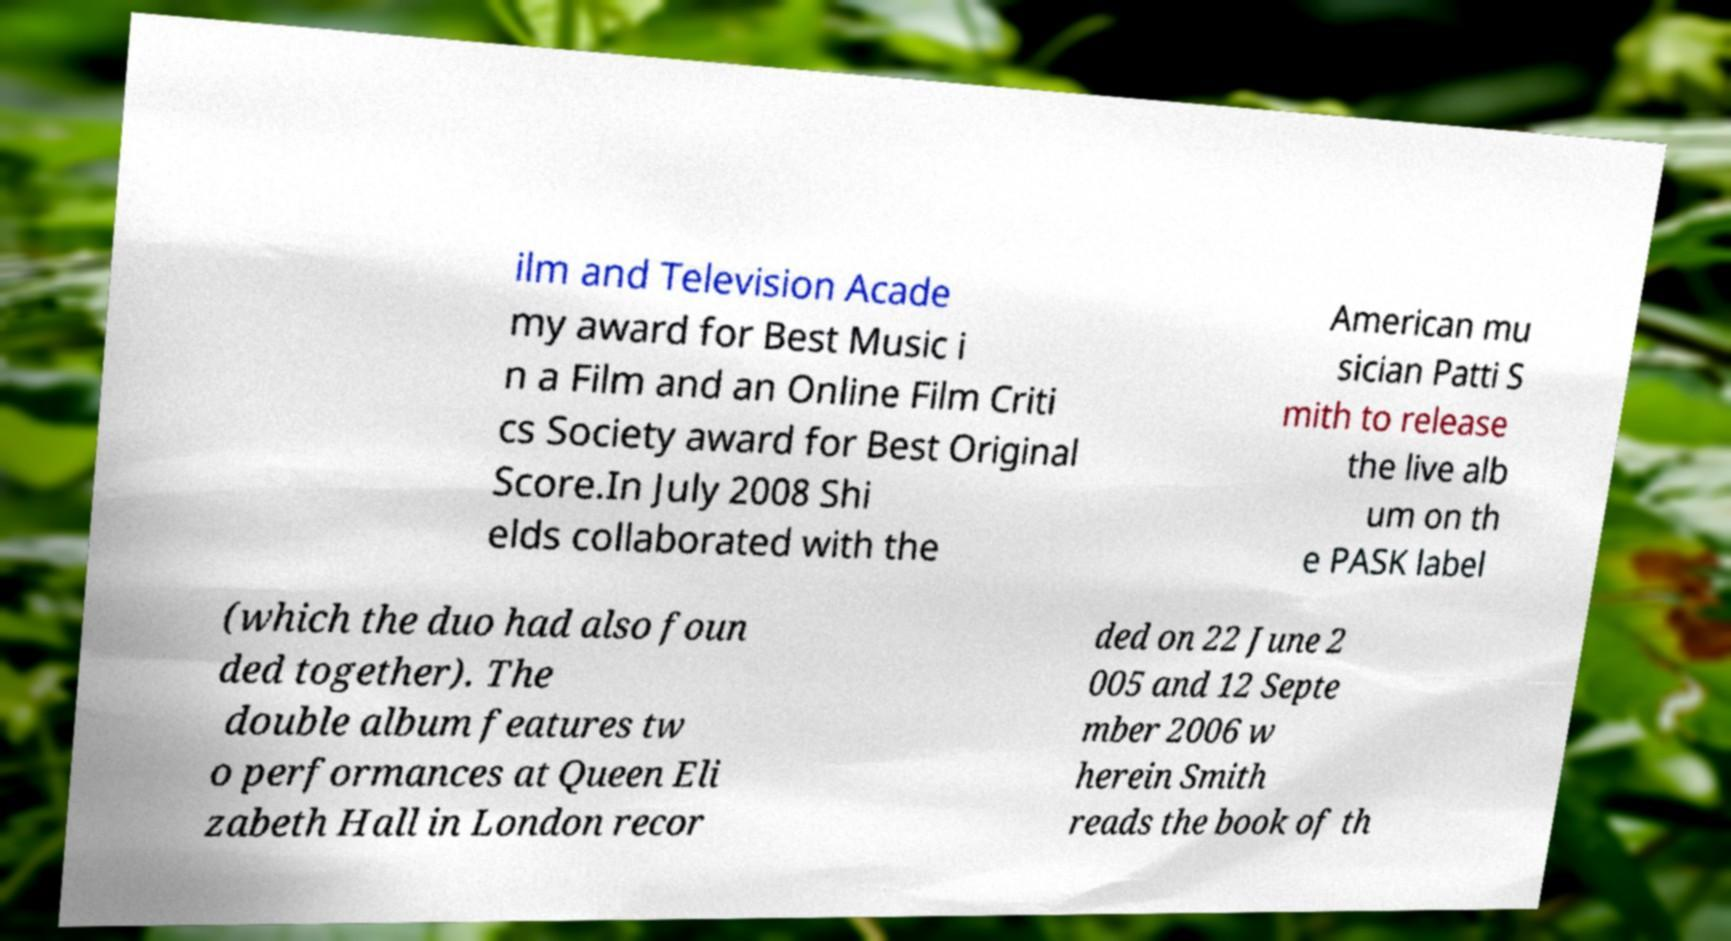Could you assist in decoding the text presented in this image and type it out clearly? ilm and Television Acade my award for Best Music i n a Film and an Online Film Criti cs Society award for Best Original Score.In July 2008 Shi elds collaborated with the American mu sician Patti S mith to release the live alb um on th e PASK label (which the duo had also foun ded together). The double album features tw o performances at Queen Eli zabeth Hall in London recor ded on 22 June 2 005 and 12 Septe mber 2006 w herein Smith reads the book of th 